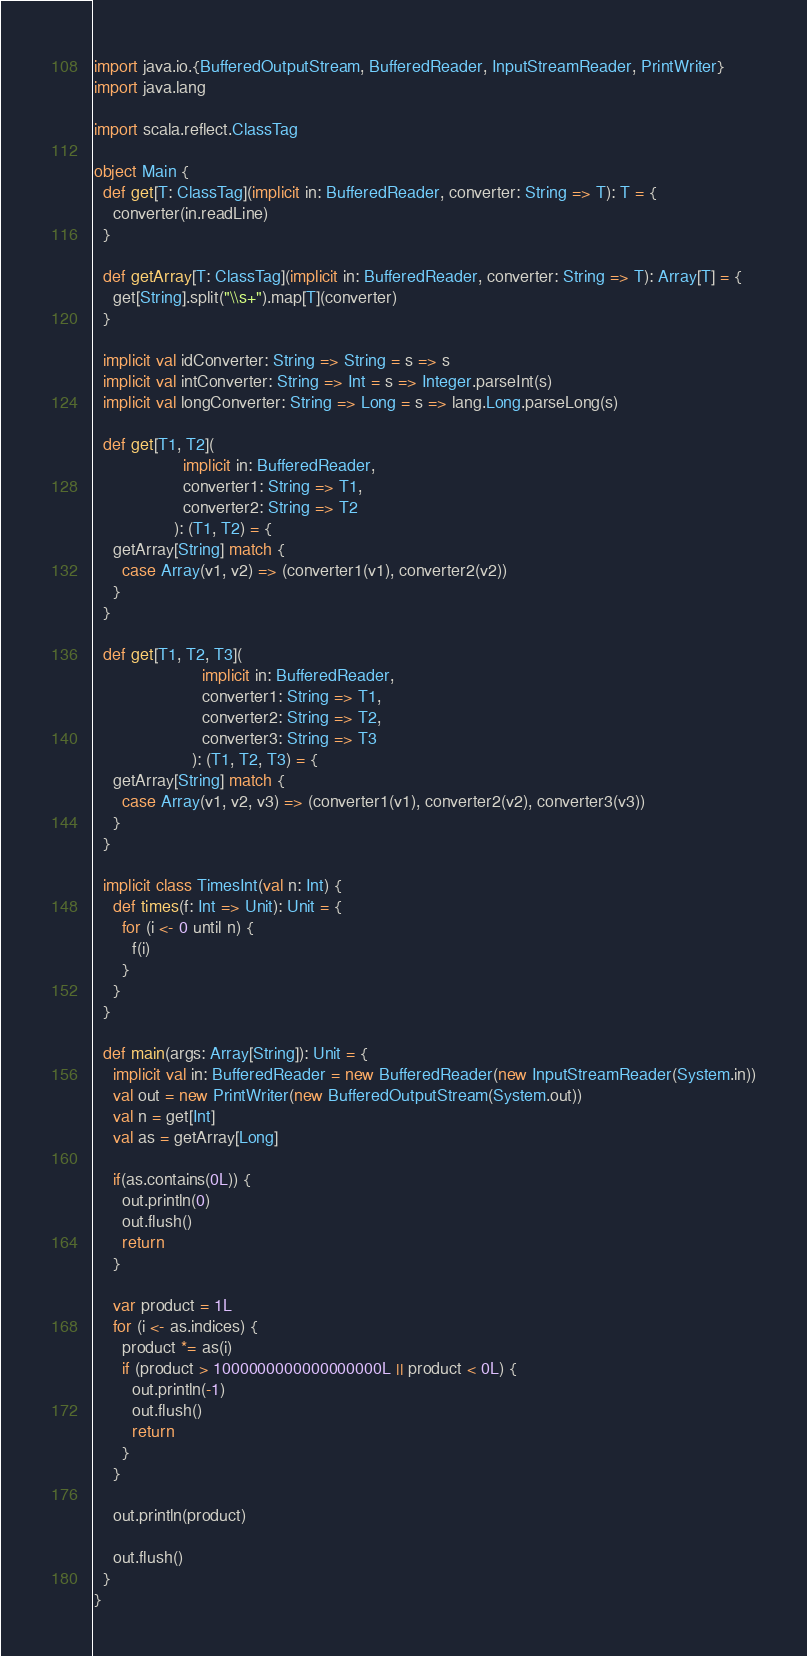<code> <loc_0><loc_0><loc_500><loc_500><_Scala_>import java.io.{BufferedOutputStream, BufferedReader, InputStreamReader, PrintWriter}
import java.lang

import scala.reflect.ClassTag

object Main {
  def get[T: ClassTag](implicit in: BufferedReader, converter: String => T): T = {
    converter(in.readLine)
  }

  def getArray[T: ClassTag](implicit in: BufferedReader, converter: String => T): Array[T] = {
    get[String].split("\\s+").map[T](converter)
  }

  implicit val idConverter: String => String = s => s
  implicit val intConverter: String => Int = s => Integer.parseInt(s)
  implicit val longConverter: String => Long = s => lang.Long.parseLong(s)

  def get[T1, T2](
                   implicit in: BufferedReader,
                   converter1: String => T1,
                   converter2: String => T2
                 ): (T1, T2) = {
    getArray[String] match {
      case Array(v1, v2) => (converter1(v1), converter2(v2))
    }
  }

  def get[T1, T2, T3](
                       implicit in: BufferedReader,
                       converter1: String => T1,
                       converter2: String => T2,
                       converter3: String => T3
                     ): (T1, T2, T3) = {
    getArray[String] match {
      case Array(v1, v2, v3) => (converter1(v1), converter2(v2), converter3(v3))
    }
  }

  implicit class TimesInt(val n: Int) {
    def times(f: Int => Unit): Unit = {
      for (i <- 0 until n) {
        f(i)
      }
    }
  }

  def main(args: Array[String]): Unit = {
    implicit val in: BufferedReader = new BufferedReader(new InputStreamReader(System.in))
    val out = new PrintWriter(new BufferedOutputStream(System.out))
    val n = get[Int]
    val as = getArray[Long]

    if(as.contains(0L)) {
      out.println(0)
      out.flush()
      return
    }

    var product = 1L
    for (i <- as.indices) {
      product *= as(i)
      if (product > 1000000000000000000L || product < 0L) {
        out.println(-1)
        out.flush()
        return
      }
    }

    out.println(product)

    out.flush()
  }
}</code> 